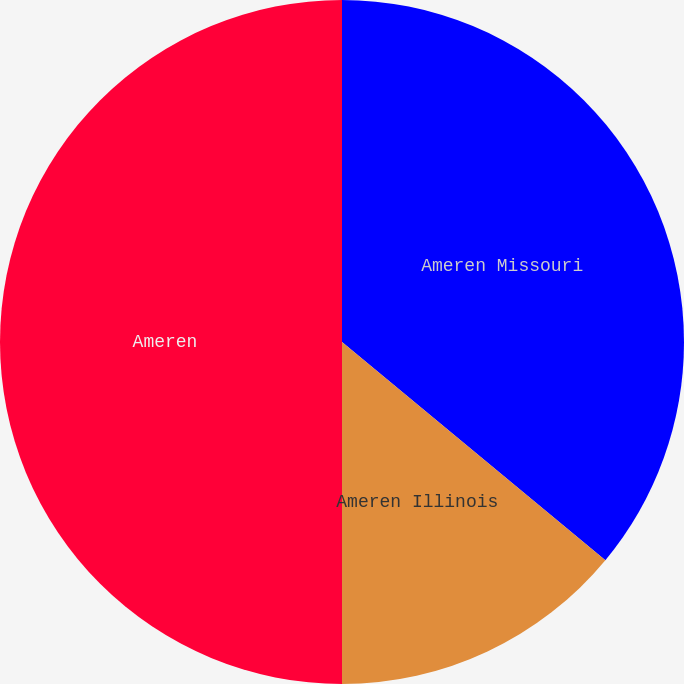Convert chart. <chart><loc_0><loc_0><loc_500><loc_500><pie_chart><fcel>Ameren Missouri<fcel>Ameren Illinois<fcel>Ameren<nl><fcel>36.01%<fcel>13.99%<fcel>50.0%<nl></chart> 